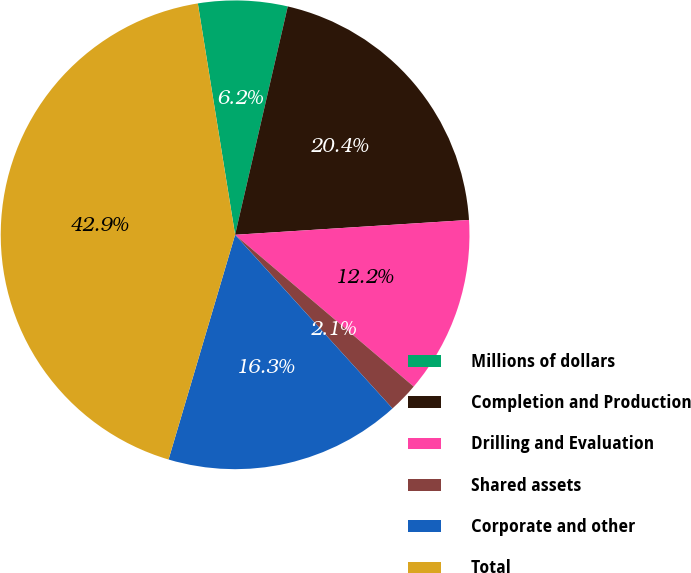Convert chart to OTSL. <chart><loc_0><loc_0><loc_500><loc_500><pie_chart><fcel>Millions of dollars<fcel>Completion and Production<fcel>Drilling and Evaluation<fcel>Shared assets<fcel>Corporate and other<fcel>Total<nl><fcel>6.15%<fcel>20.38%<fcel>12.22%<fcel>2.07%<fcel>16.3%<fcel>42.87%<nl></chart> 